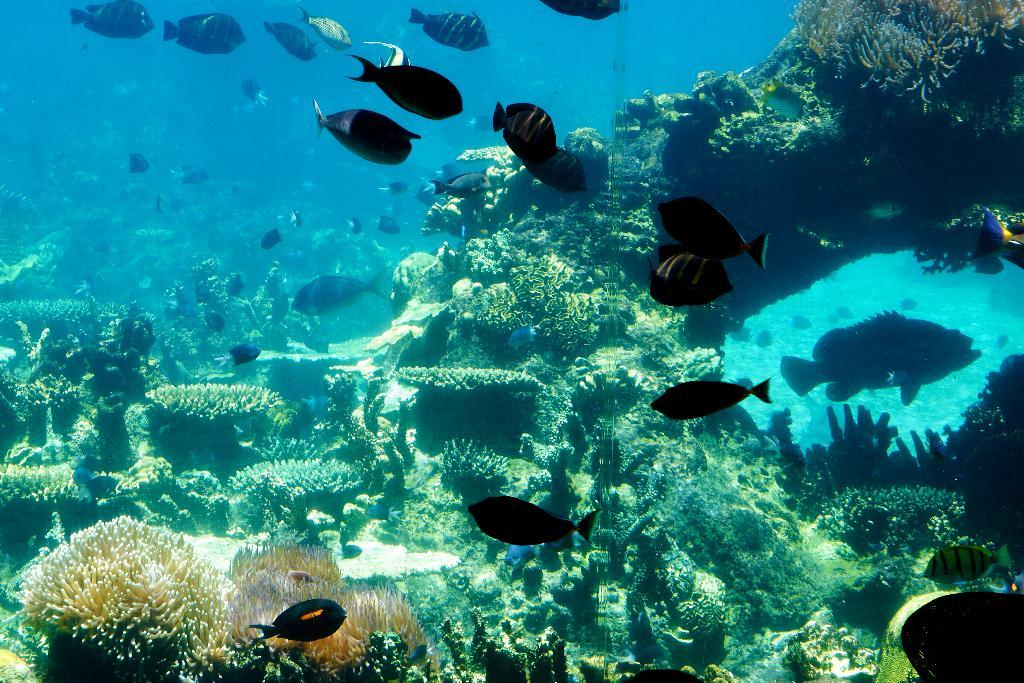What is the main subject of the image? The main subject of the image is an inside view of water. What can be seen in the water? There are fishes and aquatic plants present in the water. What type of baby is swimming with the fishes in the image? There is no baby present in the image; it only shows fishes and aquatic plants in the water. 